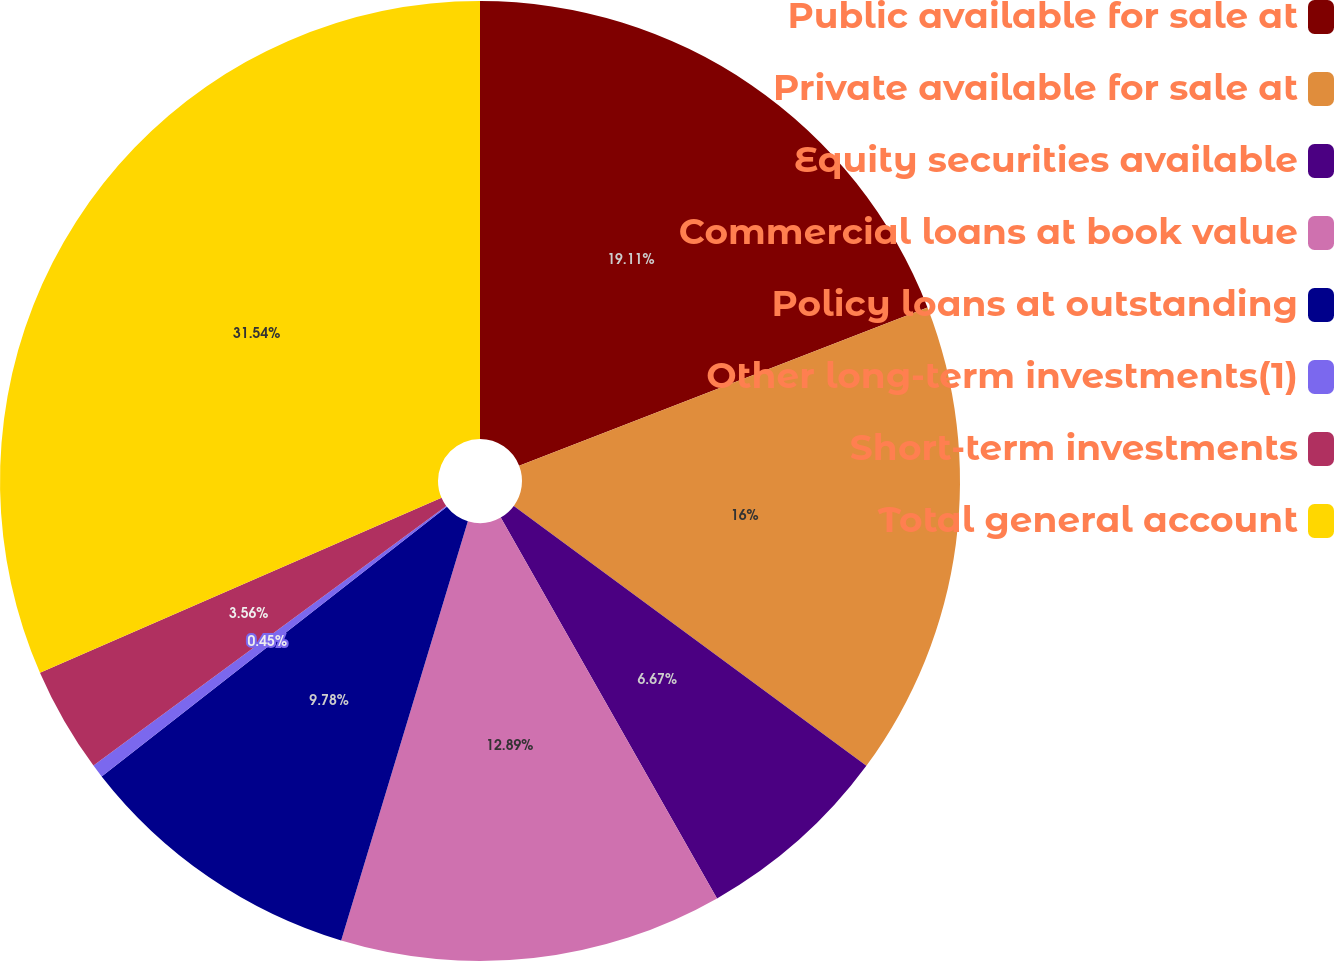Convert chart. <chart><loc_0><loc_0><loc_500><loc_500><pie_chart><fcel>Public available for sale at<fcel>Private available for sale at<fcel>Equity securities available<fcel>Commercial loans at book value<fcel>Policy loans at outstanding<fcel>Other long-term investments(1)<fcel>Short-term investments<fcel>Total general account<nl><fcel>19.11%<fcel>16.0%<fcel>6.67%<fcel>12.89%<fcel>9.78%<fcel>0.45%<fcel>3.56%<fcel>31.54%<nl></chart> 